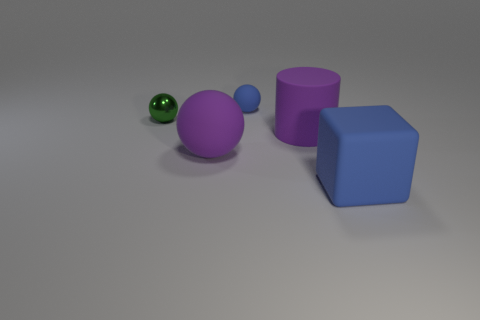Subtract all tiny balls. How many balls are left? 1 Add 3 small purple cubes. How many objects exist? 8 Subtract 2 balls. How many balls are left? 1 Subtract all cyan balls. Subtract all yellow cubes. How many balls are left? 3 Subtract all blue cubes. How many blue spheres are left? 1 Subtract all large red balls. Subtract all tiny matte objects. How many objects are left? 4 Add 1 blue matte blocks. How many blue matte blocks are left? 2 Add 4 small green balls. How many small green balls exist? 5 Subtract all purple balls. How many balls are left? 2 Subtract 0 cyan spheres. How many objects are left? 5 